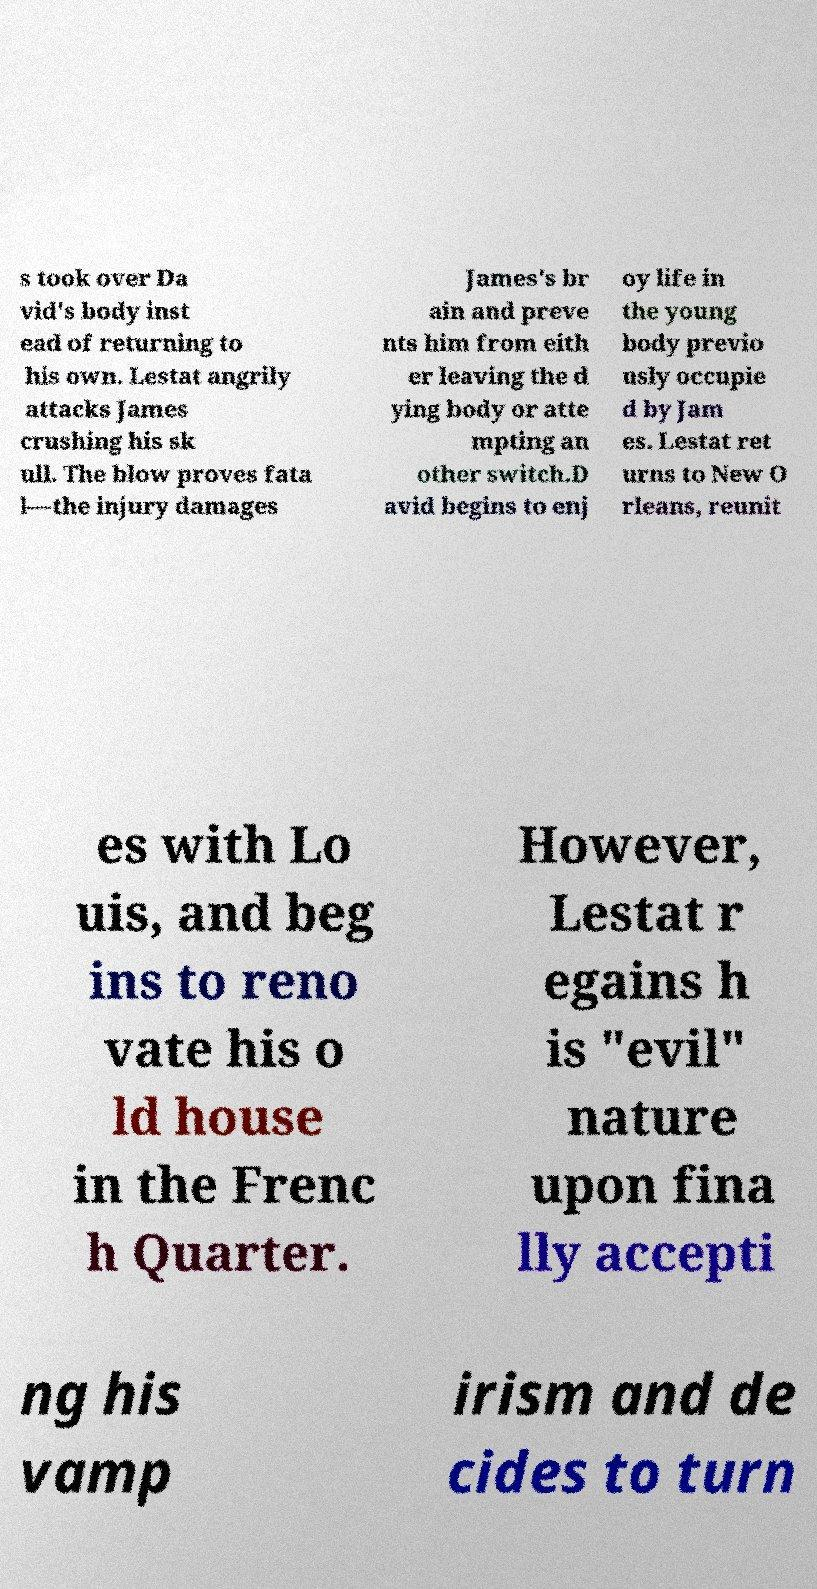For documentation purposes, I need the text within this image transcribed. Could you provide that? s took over Da vid's body inst ead of returning to his own. Lestat angrily attacks James crushing his sk ull. The blow proves fata l—the injury damages James's br ain and preve nts him from eith er leaving the d ying body or atte mpting an other switch.D avid begins to enj oy life in the young body previo usly occupie d by Jam es. Lestat ret urns to New O rleans, reunit es with Lo uis, and beg ins to reno vate his o ld house in the Frenc h Quarter. However, Lestat r egains h is "evil" nature upon fina lly accepti ng his vamp irism and de cides to turn 